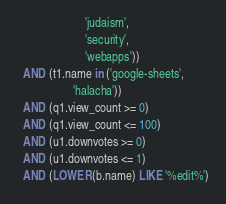Convert code to text. <code><loc_0><loc_0><loc_500><loc_500><_SQL_>                       'judaism',
                       'security',
                       'webapps'))
  AND (t1.name in ('google-sheets',
                   'halacha'))
  AND (q1.view_count >= 0)
  AND (q1.view_count <= 100)
  AND (u1.downvotes >= 0)
  AND (u1.downvotes <= 1)
  AND (LOWER(b.name) LIKE '%edit%')</code> 